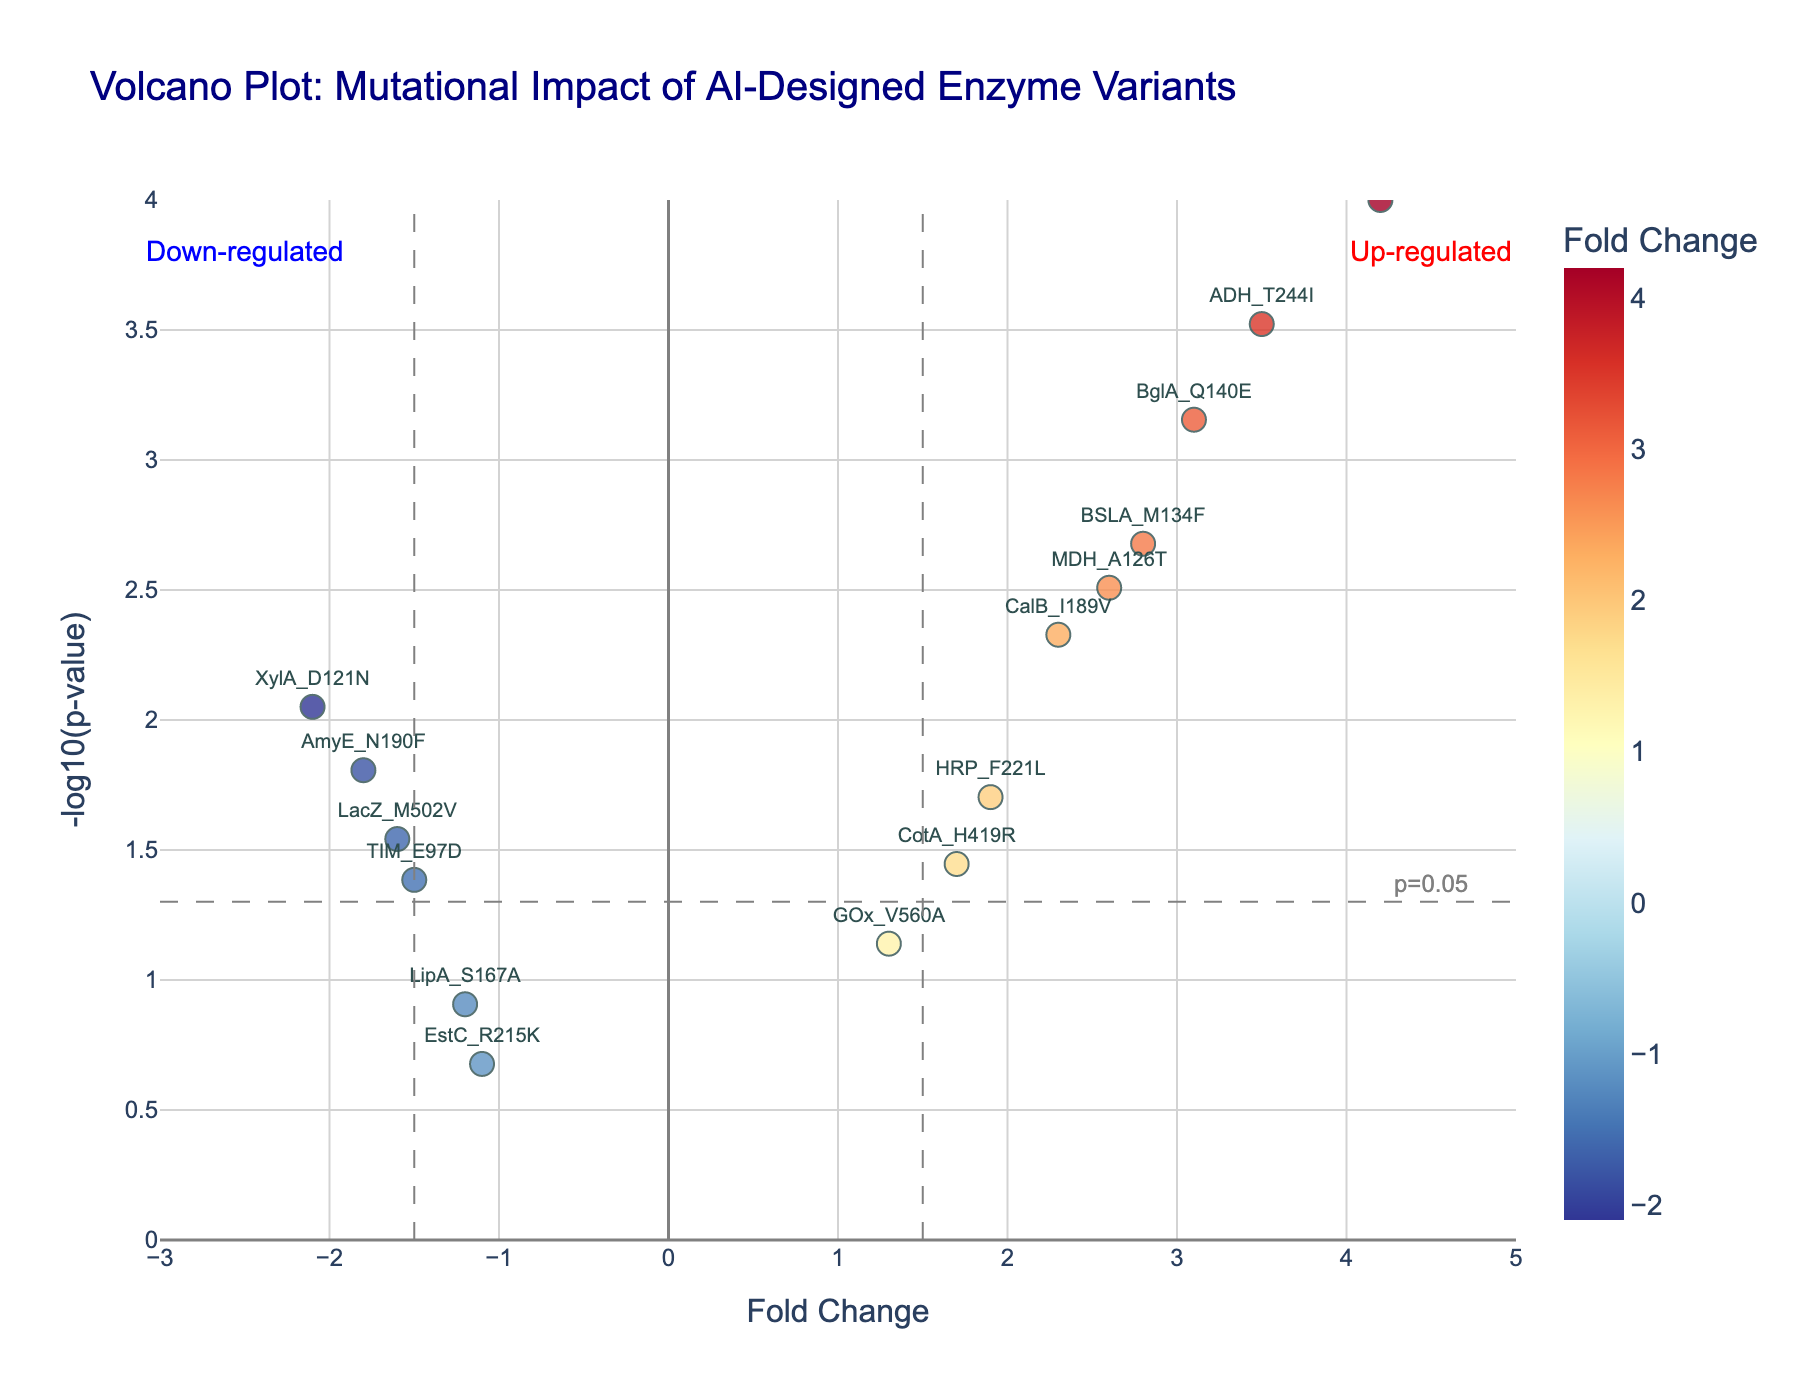What is the title of the plot? The title can be found at the top of the plot in a larger font and navy color.
Answer: Volcano Plot: Mutational Impact of AI-Designed Enzyme Variants How many enzyme variants are analyzed in this plot? Each enzyme variant corresponds to one data point in the scatter plot. Count the number of data points or the number of enzyme_variant labels in the plot.
Answer: 15 What are the fold change threshold values indicated by vertical dashed lines? The vertical dashed lines are located at specific fold change values representing thresholds. Observe the x-axis where these lines intersect.
Answer: -1.5, 1.5 What is the p-value threshold indicated by the horizontal dashed line? The horizontal dashed line represents a p-value threshold. Look at the y-axis value where this line is placed and note the label next to it.
Answer: 0.05 Which enzyme variant has the highest fold change? Identify the data point farthest to the right on the x-axis (fold change) and check its label.
Answer: PETase_W159H Which enzyme variant has the lowest fold change? Identify the data point farthest to the left on the x-axis (fold change) and check its label.
Answer: XylA_D121N Which enzyme variant has the smallest p-value (highest -log10(p-value))? Identify the data point highest on the y-axis (-log10(p-value)) and check its label.
Answer: PETase_W159H Are there any down-regulated enzyme variants with a fold change less than -1.5? Check the points left of the -1.5 vertical dashed line and cross-check if any fall under down-regulated annotation.
Answer: Yes How many enzyme variants fall in the "up-regulated" region with significant p-values? The up-regulated region is to the right of fold change > 1.5. Count the points in this region cross verifying they also are above the horizontal p-value threshold.
Answer: 5 Which enzyme variants are both significantly up-regulated and have a -log10(p-value) > 3? Identify points to the right of the 1.5 fold change line and above 3 on the y-axis for -log10(p-value). List their labels.
Answer: PETase_W159H 